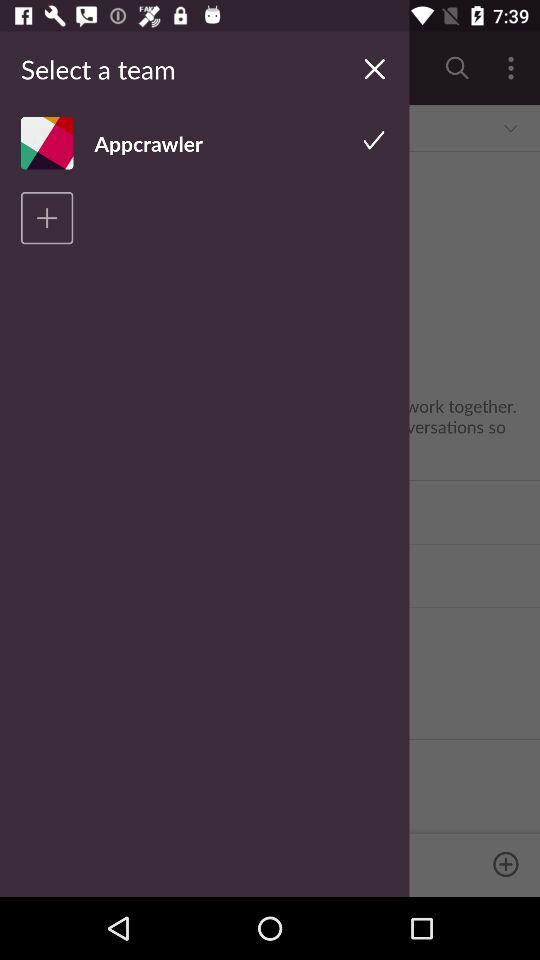What is the name of the user? The name of the user is Appcrawler. 